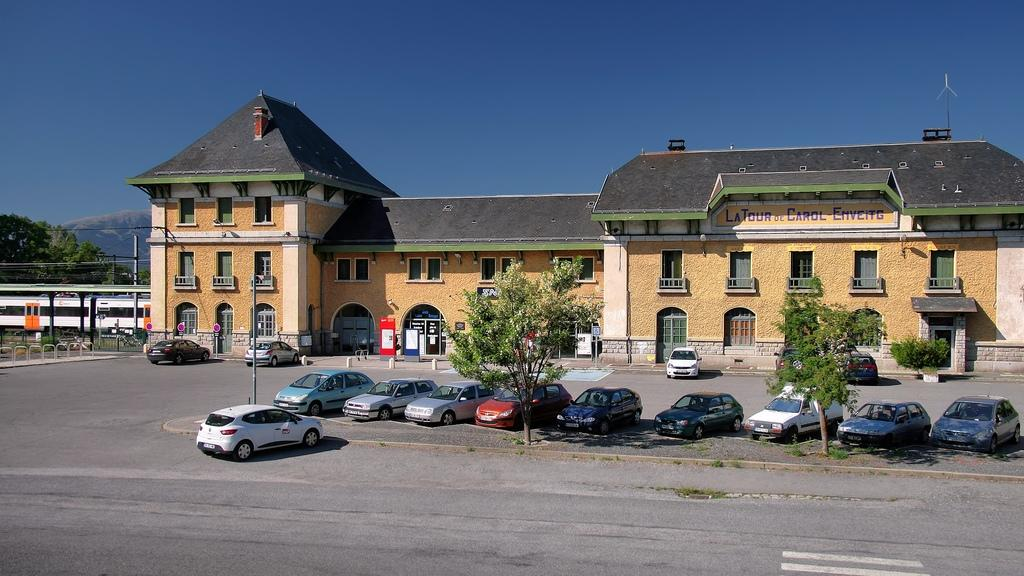What type of structure can be seen in the image? There is a building in the image. What natural elements are present in the image? There are trees in the image. What type of barrier is visible in the image? There is a fence in the image. What type of transportation is present in the image? Vehicles are present on the road in the image. What type of vertical structures are present in the image? There are poles in the image. What other objects can be seen on the ground in the image? There are other objects on the ground in the image. What can be seen in the background of the image? The sky is visible in the background of the image. What type of joke is being told by the tree in the image? There is no joke being told by the tree in the image, as trees are not capable of telling jokes. What type of protest is happening in the image? There is no protest happening in the image; it only shows a building, trees, a fence, vehicles, poles, other objects on the ground, and the sky in the background. 